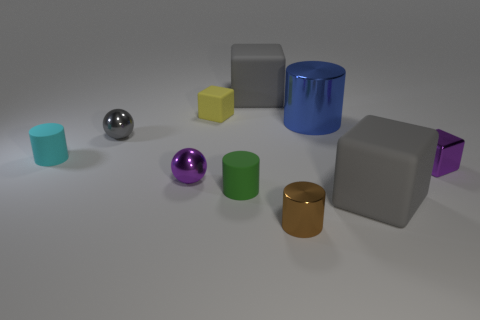What number of purple things are small metallic blocks or large rubber blocks?
Ensure brevity in your answer.  1. Are the blue cylinder and the small brown cylinder made of the same material?
Provide a short and direct response. Yes. How many tiny cyan rubber things are behind the tiny gray sphere?
Provide a succinct answer. 0. What is the material of the gray thing that is in front of the small yellow block and to the right of the small yellow rubber object?
Your answer should be compact. Rubber. What number of cubes are either small purple metal things or small brown objects?
Your response must be concise. 1. What is the material of the green thing that is the same shape as the large blue shiny object?
Give a very brief answer. Rubber. There is a gray thing that is made of the same material as the blue cylinder; what size is it?
Provide a short and direct response. Small. Do the matte object that is to the left of the yellow rubber block and the purple object right of the small brown metal thing have the same shape?
Your answer should be very brief. No. What is the color of the large object that is the same material as the small purple cube?
Make the answer very short. Blue. There is a matte cylinder that is to the right of the tiny purple metal sphere; is it the same size as the metal sphere behind the purple metallic sphere?
Offer a terse response. Yes. 